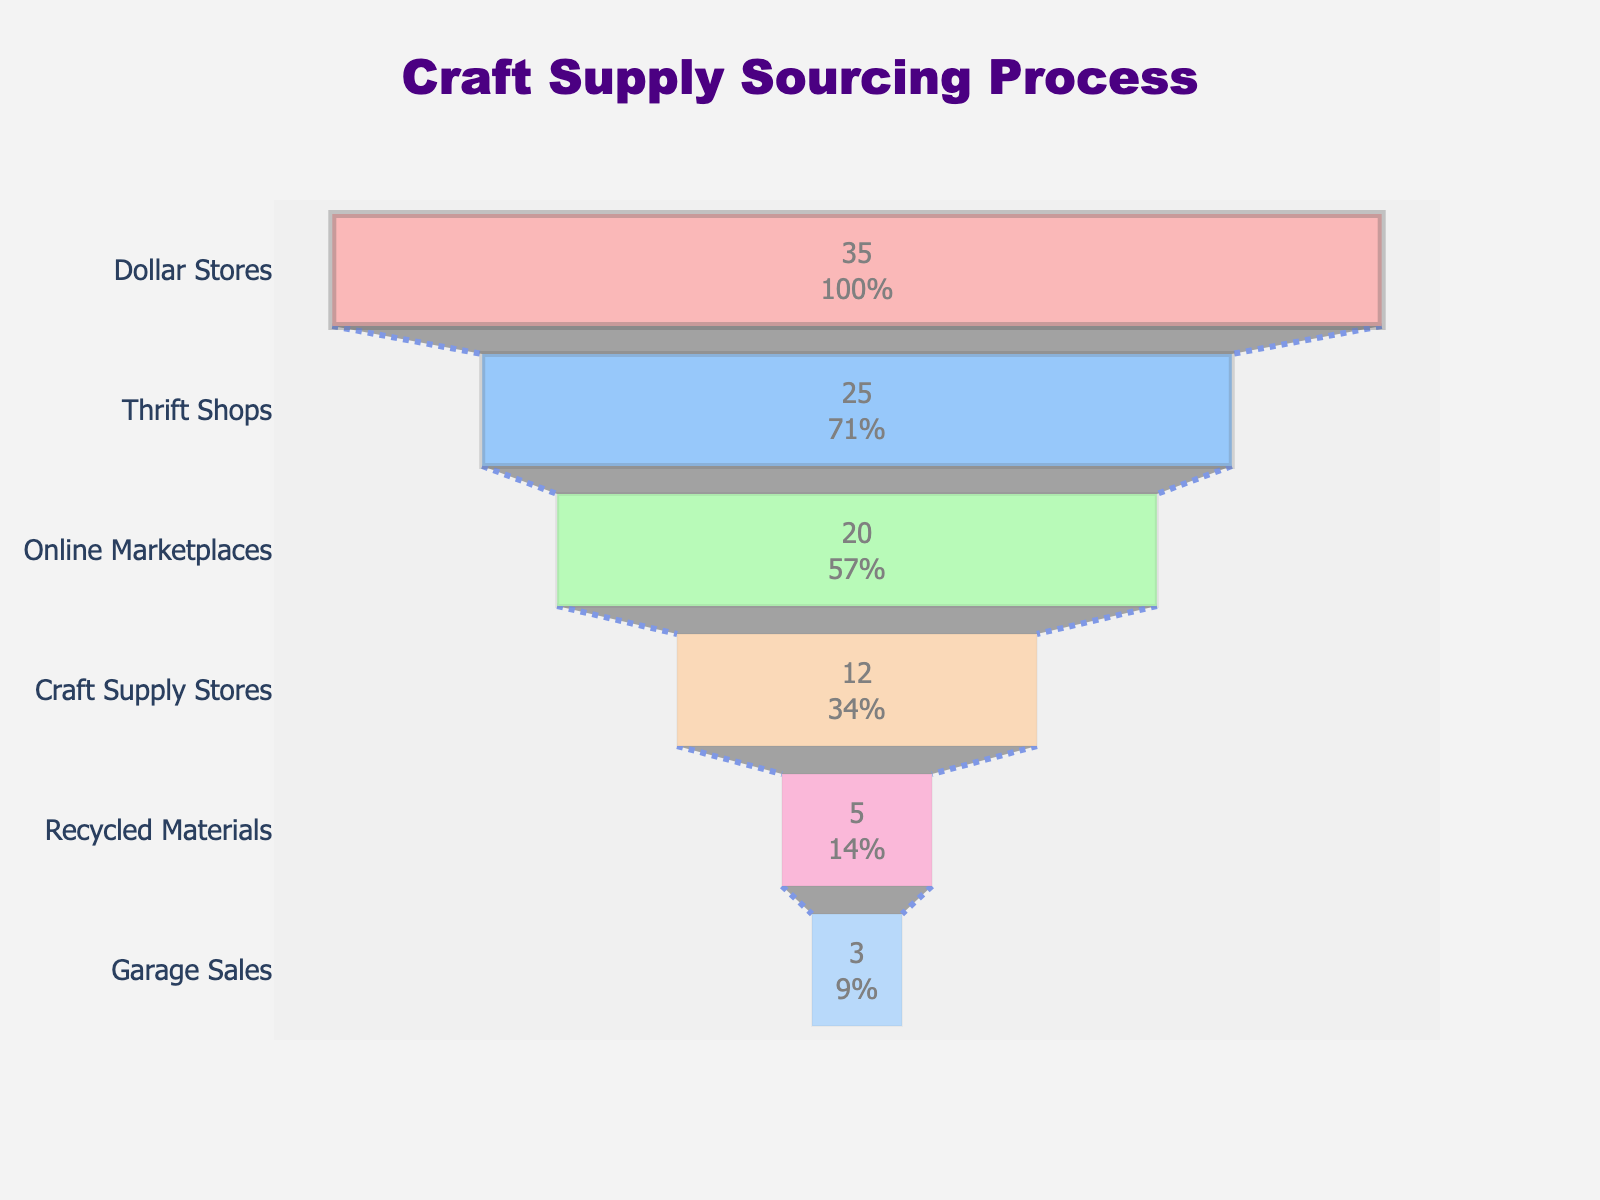What is the title of the funnel chart? The title of the chart is usually displayed at the top and is larger and more prominent than other text elements. From the provided details, the title of the chart is "Craft Supply Sourcing Process."
Answer: Craft Supply Sourcing Process Which stage has the highest percentage of materials obtained? The highest point in the funnel chart is the widest segment with the highest percentage. According to the data, the "Dollar Stores" stage has the highest percentage of 35%.
Answer: Dollar Stores What is the total percentage of materials obtained from Thrift Shops and Online Marketplaces combined? To find the total, simply add the percentages for Thrift Shops and Online Marketplaces: 25% + 20% = 45%.
Answer: 45% By how much does the percentage of materials obtained from Craft Supply Stores differ from Dollar Stores? Subtract the percentage for Craft Supply Stores from Dollar Stores: 35% - 12% = 23%.
Answer: 23% What are the stages with a percentage less than 10%? From the data provided, the stages with percentages less than 10% are Recycled Materials (5%) and Garage Sales (3%).
Answer: Recycled Materials, Garage Sales If you combine the percentages for Recycled Materials and Garage Sales, do they exceed the percentage for Online Marketplaces? Add the percentages for Recycled Materials and Garage Sales: 5% + 3% = 8%. Compare this to Online Marketplaces (20%). 8% does not exceed 20%.
Answer: No How many stages are displayed in the funnel chart? Count the distinct stages or segments in the funnel chart. From the data, there are six stages: Dollar Stores, Thrift Shops, Online Marketplaces, Craft Supply Stores, Recycled Materials, Garage Sales.
Answer: 6 What is the percentage difference between Thrift Shops and Craft Supply Stores? Subtract the percentage for Craft Supply Stores from Thrift Shops: 25% - 12% = 13%.
Answer: 13% Which stage falls exactly in the middle in terms of percentage? Identify the middle value in the ordered list from highest to lowest percentages. With six stages (an even number), the middle two stages are Online Marketplaces (20%) and Craft Supply Stores (12%). The average of these two middle values: (20% + 12%) / 2 = 16%.
Answer: Online Marketplaces, Craft Supply Stores What percentage of materials is sourced from Online Marketplaces according to the funnel chart? Locate the "Online Marketplaces" percentage in the provided data set, which is 20%.
Answer: 20% 